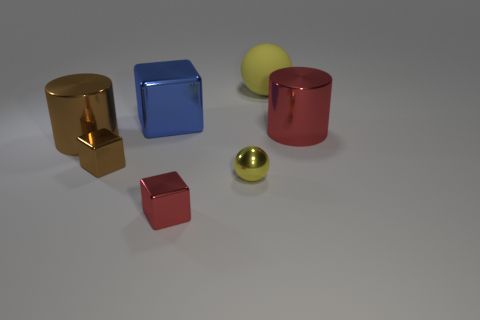There is another ball that is the same color as the large rubber ball; what material is it?
Your answer should be very brief. Metal. What is the large object that is both behind the big red metal cylinder and in front of the matte sphere made of?
Your answer should be compact. Metal. Do the large cylinder in front of the big red thing and the large blue object have the same material?
Provide a short and direct response. Yes. What is the large brown cylinder made of?
Make the answer very short. Metal. How big is the sphere in front of the large red cylinder?
Offer a very short reply. Small. Are there any other things that have the same color as the tiny metal ball?
Offer a very short reply. Yes. There is a big cylinder that is behind the large shiny cylinder that is in front of the big red metal cylinder; is there a small red block right of it?
Your answer should be very brief. No. There is a big cylinder that is on the right side of the large brown object; is it the same color as the tiny shiny sphere?
Provide a short and direct response. No. How many balls are red objects or small yellow things?
Make the answer very short. 1. The yellow thing in front of the small metal object left of the small red shiny block is what shape?
Keep it short and to the point. Sphere. 